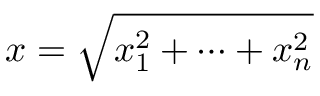Convert formula to latex. <formula><loc_0><loc_0><loc_500><loc_500>x = \sqrt { x _ { 1 } ^ { 2 } + \cdots + x _ { n } ^ { 2 } }</formula> 